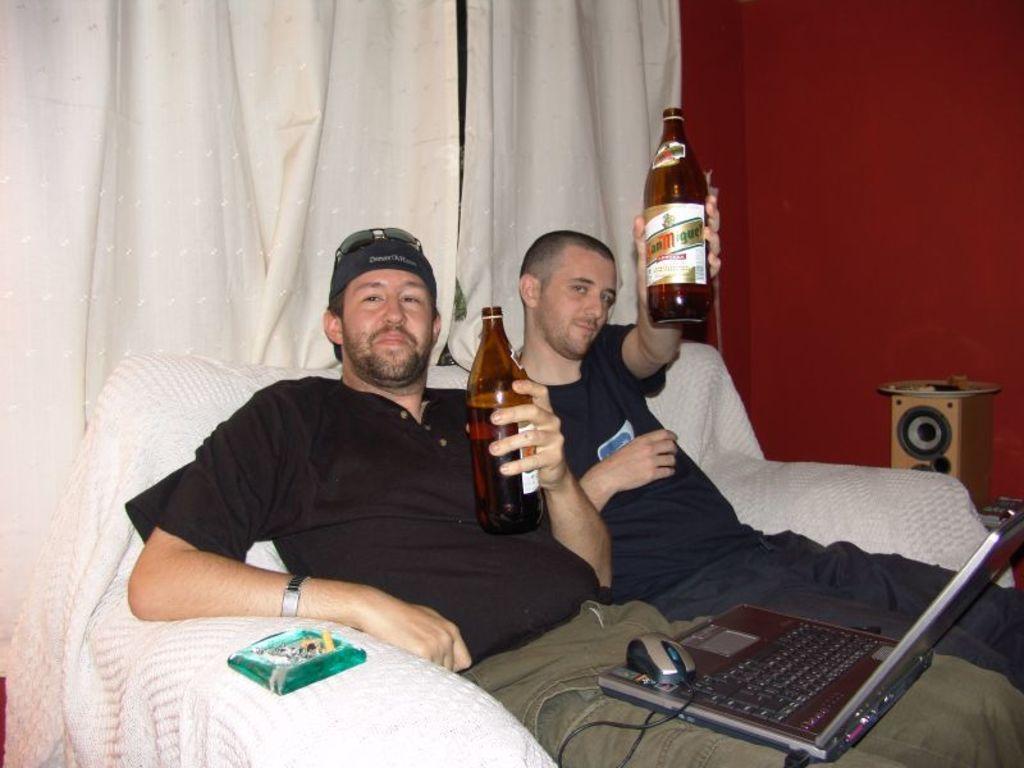Describe this image in one or two sentences. In this image in the center there are two persons who are sitting on a couch and they are holding bottles in front of them there is one laptop and mouse is there. On the background there are curtains and on the right side there is a wall. 